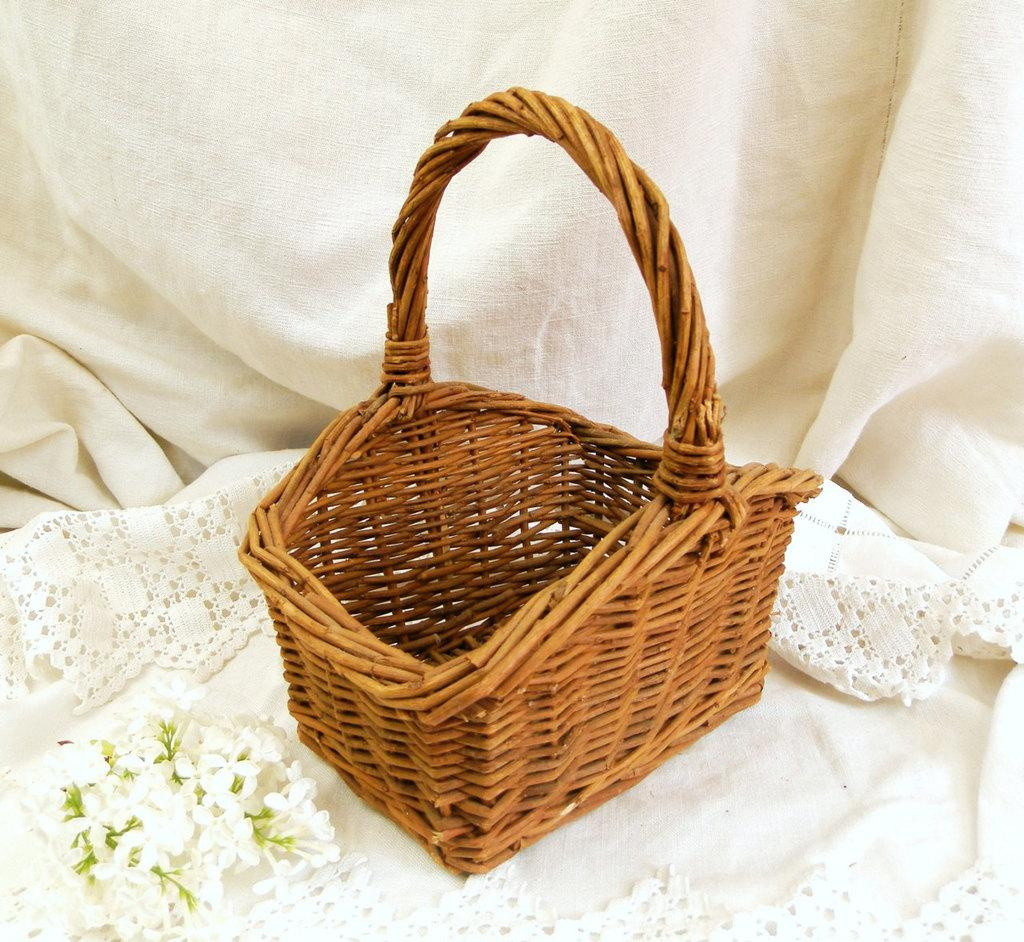What object can be seen in the image? There is a basket in the image. What is placed on the cloth in the image? There are flowers on a cloth in the image. What is visible in the background of the image? The background of the image includes a cloth. What type of society is depicted in the image? There is no depiction of a society in the image; it features a basket, flowers, and a cloth. What time of day is it in the image? The time of day is not specified in the image, as there are no indicators of day or night. 